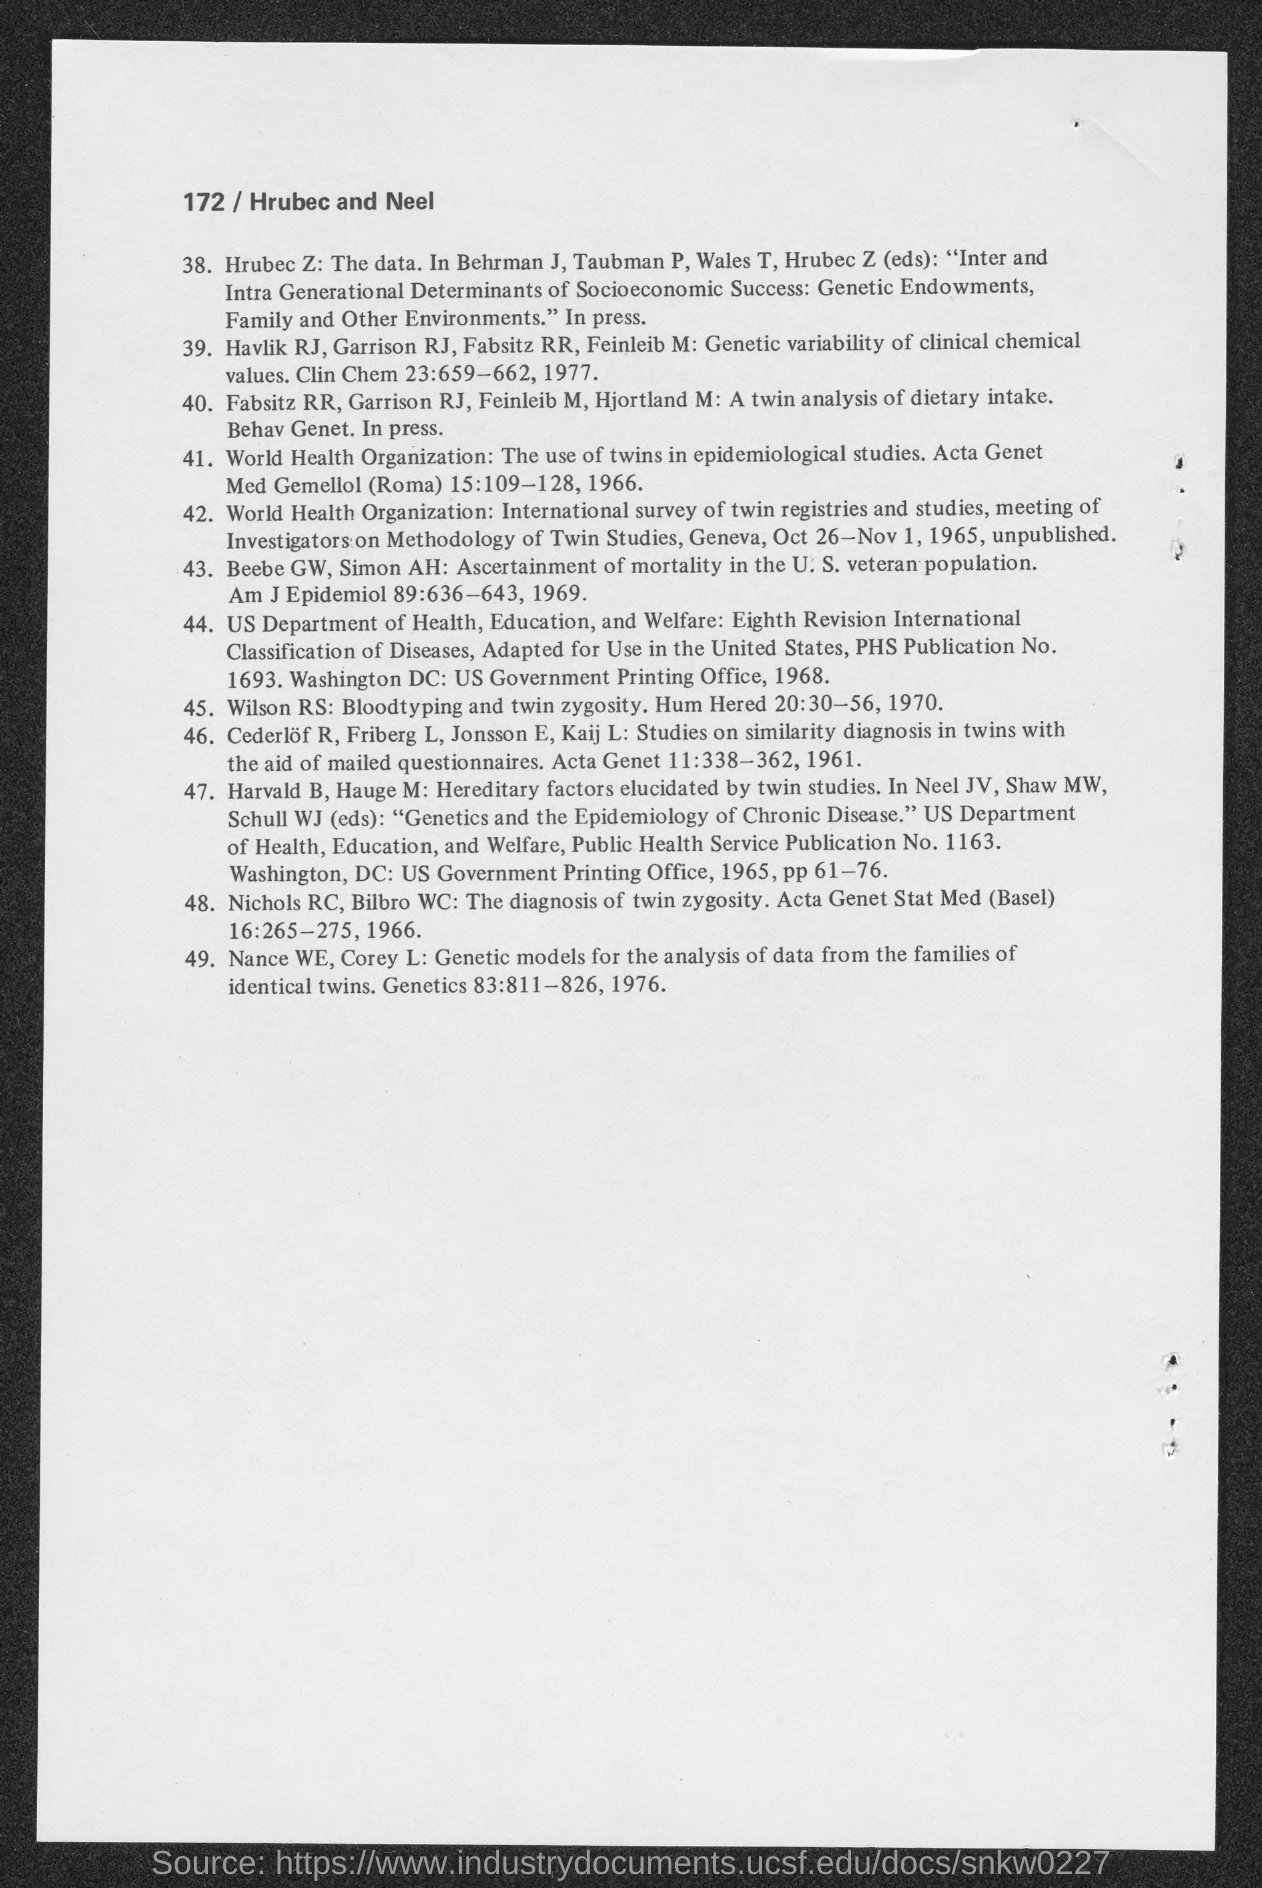Draw attention to some important aspects in this diagram. In 1976, Nance WE published his book. 